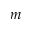Convert formula to latex. <formula><loc_0><loc_0><loc_500><loc_500>m</formula> 